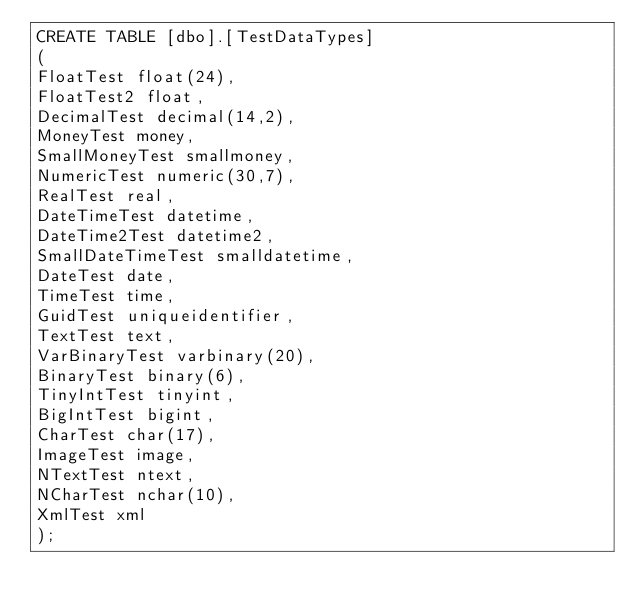Convert code to text. <code><loc_0><loc_0><loc_500><loc_500><_SQL_>CREATE TABLE [dbo].[TestDataTypes]
(
FloatTest float(24), 
FloatTest2 float,
DecimalTest decimal(14,2), 
MoneyTest money, 
SmallMoneyTest smallmoney,
NumericTest numeric(30,7),
RealTest real,
DateTimeTest datetime,
DateTime2Test datetime2,
SmallDateTimeTest smalldatetime,
DateTest date,
TimeTest time,
GuidTest uniqueidentifier,
TextTest text,
VarBinaryTest varbinary(20),
BinaryTest binary(6),
TinyIntTest tinyint,
BigIntTest bigint,
CharTest char(17),
ImageTest image,
NTextTest ntext,
NCharTest nchar(10),
XmlTest xml
);</code> 